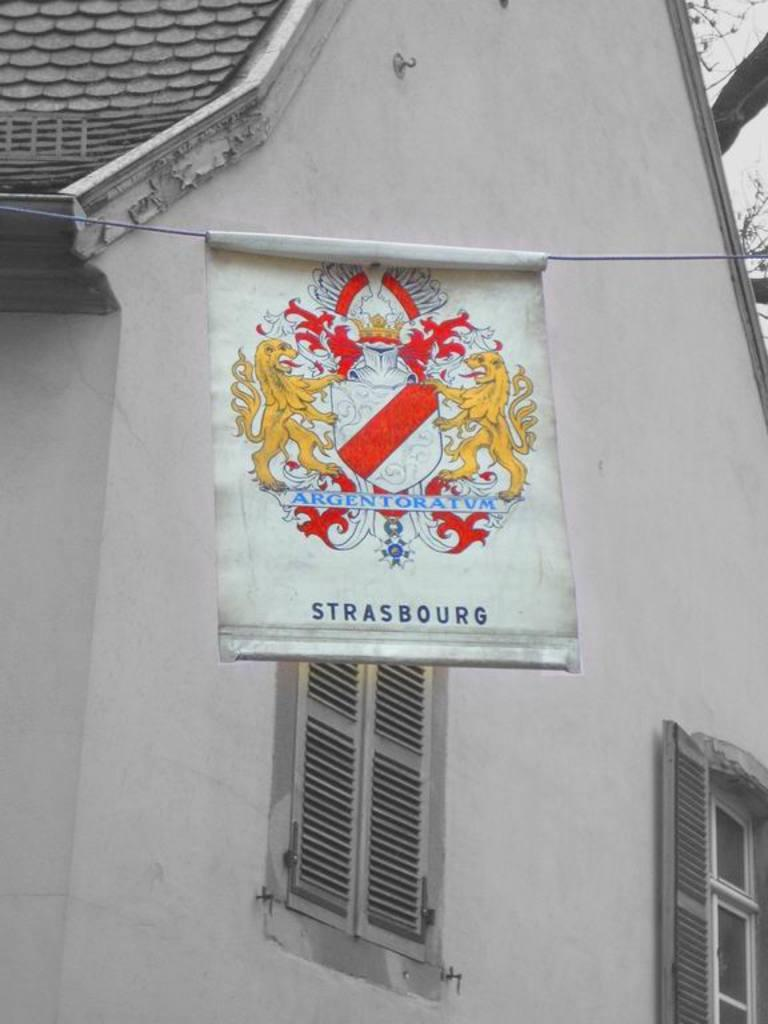What is attached to the rope in the image? There is a flag attached to the rope in the image. What can be seen on the flag? The flag has a logo and text on it. What type of structure is visible in the image? There is a house in the image. What are the main features of the house? The house has a roof, walls, and two windows. How many cakes are being used to support the flag in the image? There are no cakes present in the image; the flag is attached to a rope. What type of ball is being used to play a game in the image? There is no ball or game being played in the image. 